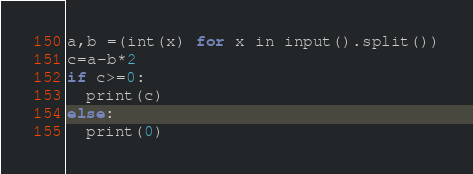<code> <loc_0><loc_0><loc_500><loc_500><_Python_>a,b =(int(x) for x in input().split())
c=a-b*2
if c>=0:
  print(c)
else:
  print(0)
</code> 